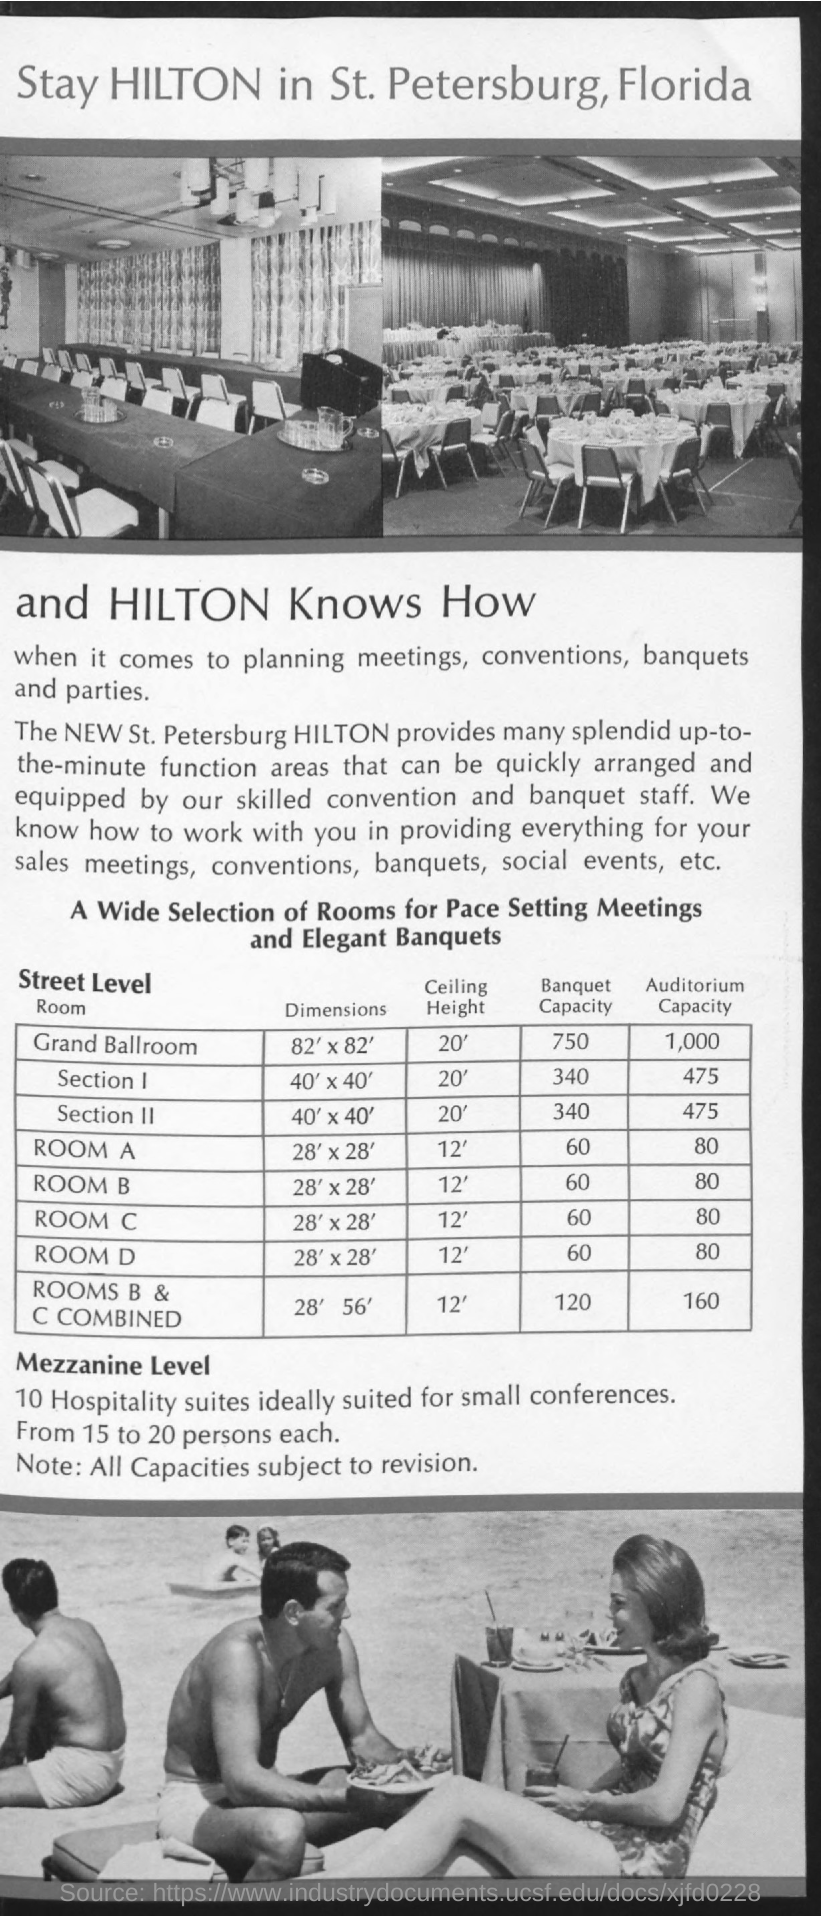Can you tell me the capacity for a banquet setting in the Grand Ballroom? The banquet capacity of the Grand Ballroom at the St. Petersburg Hilton is 750 people, ideal for large-scale events such as galas or wedding receptions. 